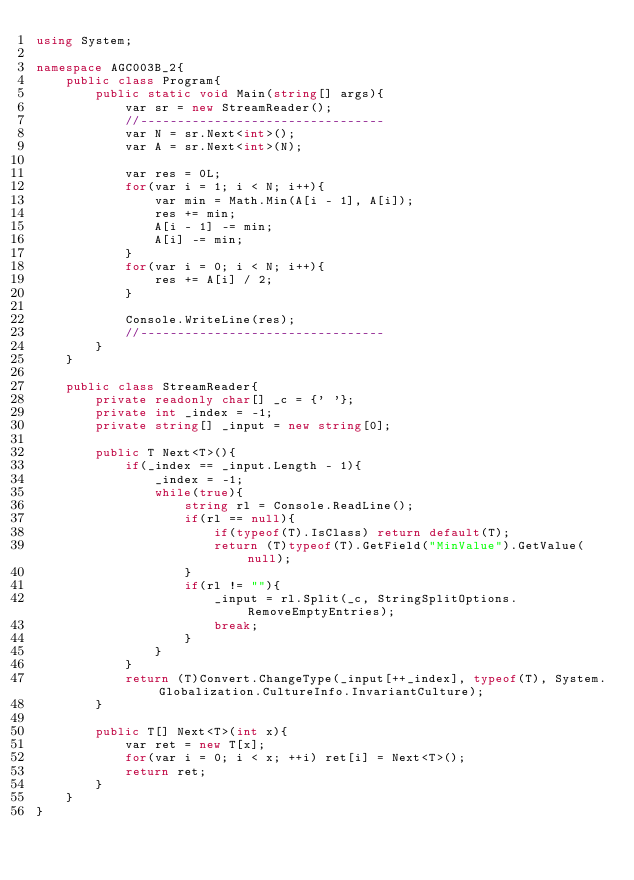Convert code to text. <code><loc_0><loc_0><loc_500><loc_500><_C#_>using System;

namespace AGC003B_2{
    public class Program{
        public static void Main(string[] args){
            var sr = new StreamReader();
            //---------------------------------
            var N = sr.Next<int>();
            var A = sr.Next<int>(N);

            var res = 0L;
            for(var i = 1; i < N; i++){
                var min = Math.Min(A[i - 1], A[i]);
                res += min;
                A[i - 1] -= min;
                A[i] -= min;
            }
            for(var i = 0; i < N; i++){
                res += A[i] / 2;
            }

            Console.WriteLine(res);
            //---------------------------------
        }
    }

    public class StreamReader{
        private readonly char[] _c = {' '};
        private int _index = -1;
        private string[] _input = new string[0];

        public T Next<T>(){
            if(_index == _input.Length - 1){
                _index = -1;
                while(true){
                    string rl = Console.ReadLine();
                    if(rl == null){
                        if(typeof(T).IsClass) return default(T);
                        return (T)typeof(T).GetField("MinValue").GetValue(null);
                    }
                    if(rl != ""){
                        _input = rl.Split(_c, StringSplitOptions.RemoveEmptyEntries);
                        break;
                    }
                }
            }
            return (T)Convert.ChangeType(_input[++_index], typeof(T), System.Globalization.CultureInfo.InvariantCulture);
        }

        public T[] Next<T>(int x){
            var ret = new T[x];
            for(var i = 0; i < x; ++i) ret[i] = Next<T>();
            return ret;
        }
    }
}</code> 